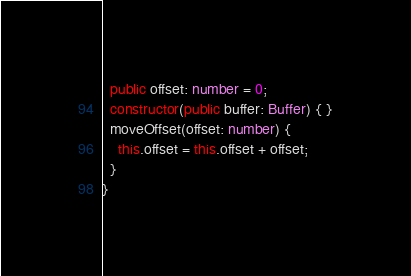Convert code to text. <code><loc_0><loc_0><loc_500><loc_500><_TypeScript_>  public offset: number = 0;
  constructor(public buffer: Buffer) { }
  moveOffset(offset: number) {
    this.offset = this.offset + offset;
  }
}
</code> 